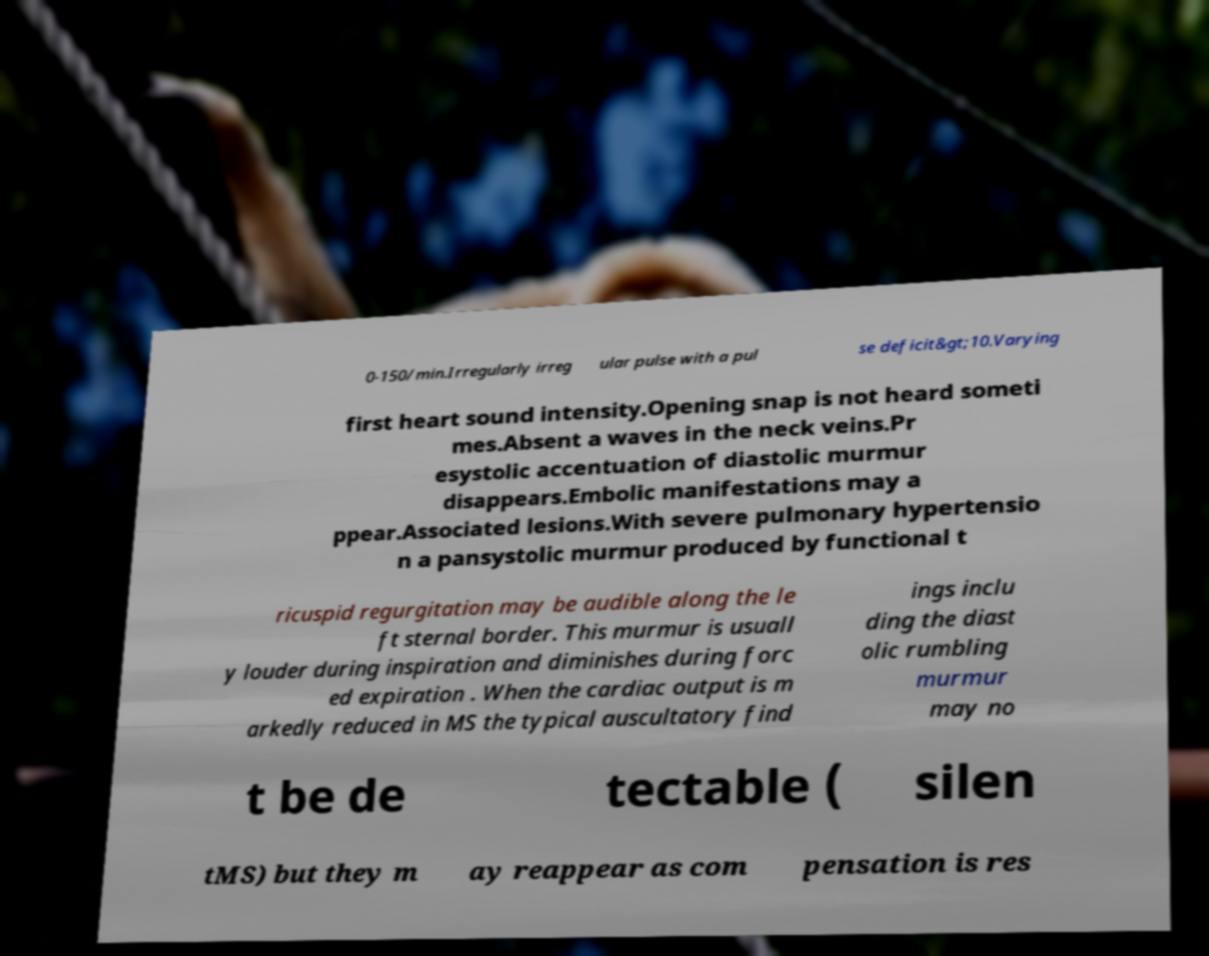Can you accurately transcribe the text from the provided image for me? 0-150/min.Irregularly irreg ular pulse with a pul se deficit&gt;10.Varying first heart sound intensity.Opening snap is not heard someti mes.Absent a waves in the neck veins.Pr esystolic accentuation of diastolic murmur disappears.Embolic manifestations may a ppear.Associated lesions.With severe pulmonary hypertensio n a pansystolic murmur produced by functional t ricuspid regurgitation may be audible along the le ft sternal border. This murmur is usuall y louder during inspiration and diminishes during forc ed expiration . When the cardiac output is m arkedly reduced in MS the typical auscultatory find ings inclu ding the diast olic rumbling murmur may no t be de tectable ( silen tMS) but they m ay reappear as com pensation is res 